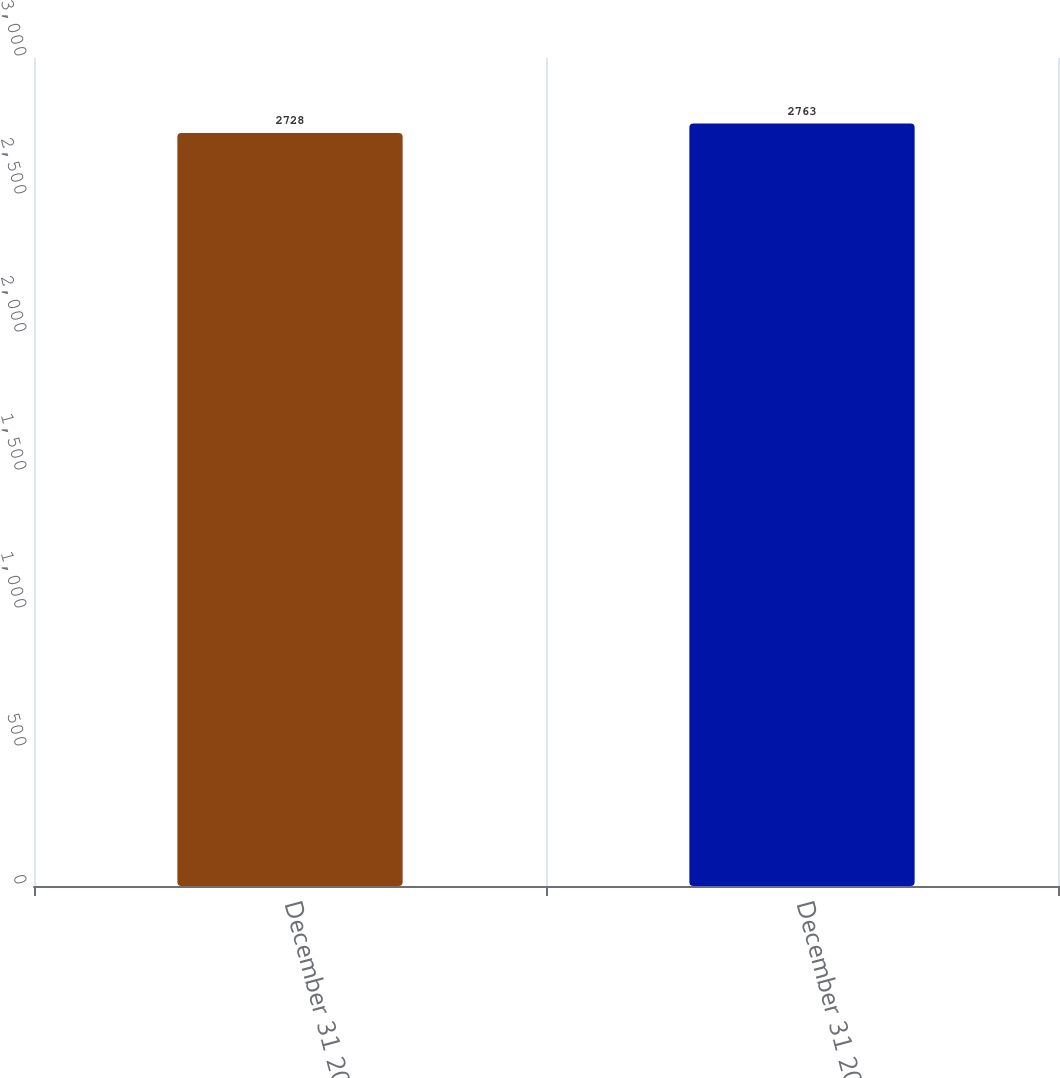Convert chart. <chart><loc_0><loc_0><loc_500><loc_500><bar_chart><fcel>December 31 2010<fcel>December 31 2011<nl><fcel>2728<fcel>2763<nl></chart> 